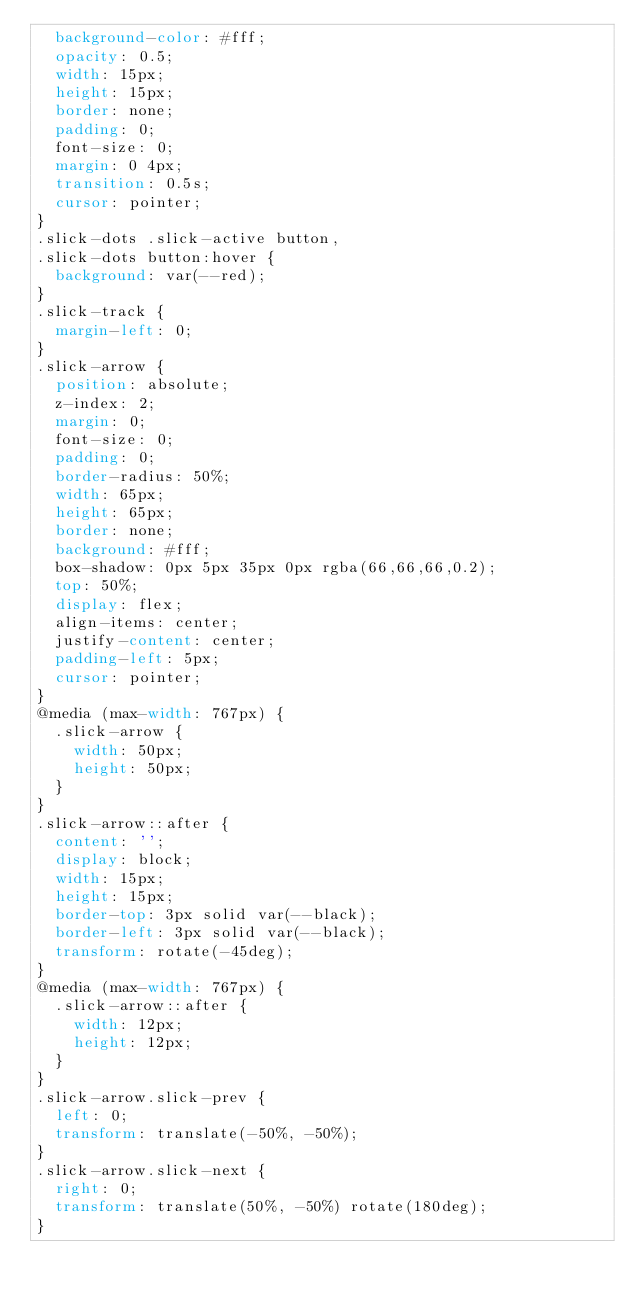<code> <loc_0><loc_0><loc_500><loc_500><_CSS_>  background-color: #fff;
  opacity: 0.5;
  width: 15px;
  height: 15px;
  border: none;
  padding: 0;
  font-size: 0;
  margin: 0 4px;
  transition: 0.5s;
  cursor: pointer;
}
.slick-dots .slick-active button,
.slick-dots button:hover {
  background: var(--red);
}
.slick-track {
  margin-left: 0;
}
.slick-arrow {
  position: absolute;
  z-index: 2;
  margin: 0;
  font-size: 0;
  padding: 0;
  border-radius: 50%;
  width: 65px;
  height: 65px;
  border: none;
  background: #fff;
  box-shadow: 0px 5px 35px 0px rgba(66,66,66,0.2);
  top: 50%;
  display: flex;
  align-items: center;
  justify-content: center;
  padding-left: 5px;
  cursor: pointer;
}
@media (max-width: 767px) {
  .slick-arrow {
    width: 50px;
    height: 50px;
  }
}
.slick-arrow::after {
  content: '';
  display: block;
  width: 15px;
  height: 15px;
  border-top: 3px solid var(--black);
  border-left: 3px solid var(--black);
  transform: rotate(-45deg);
}
@media (max-width: 767px) {
  .slick-arrow::after {
    width: 12px;
    height: 12px;
  }
}
.slick-arrow.slick-prev {
  left: 0;
  transform: translate(-50%, -50%);
}
.slick-arrow.slick-next {
  right: 0;
  transform: translate(50%, -50%) rotate(180deg);
}
</code> 